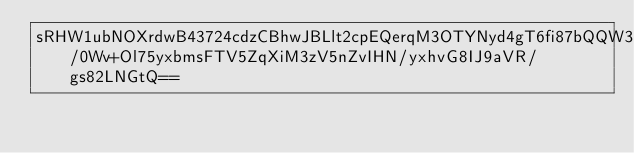Convert code to text. <code><loc_0><loc_0><loc_500><loc_500><_SML_>sRHW1ubNOXrdwB43724cdzCBhwJBLlt2cpEQerqM3OTYNyd4gT6fi87bQQW3QLLSugcmUjlPZCxfOocpONvx1EnXYorBksZThswbWeb5aOJVwkCLkuUCQgEKo5dD3tGQ5uAOeTic2KwsozHntpamhW/0Wv+Ol75yxbmsFTV5ZqXiM3zV5nZvIHN/yxhvG8IJ9aVR/gs82LNGtQ==</code> 